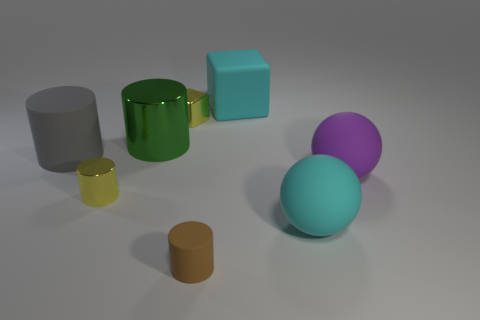Subtract all red cylinders. Subtract all green spheres. How many cylinders are left? 4 Subtract all balls. How many objects are left? 6 Add 1 brown rubber objects. How many objects exist? 9 Add 6 green cylinders. How many green cylinders exist? 7 Subtract 0 red balls. How many objects are left? 8 Subtract all big objects. Subtract all big balls. How many objects are left? 1 Add 8 big shiny objects. How many big shiny objects are left? 9 